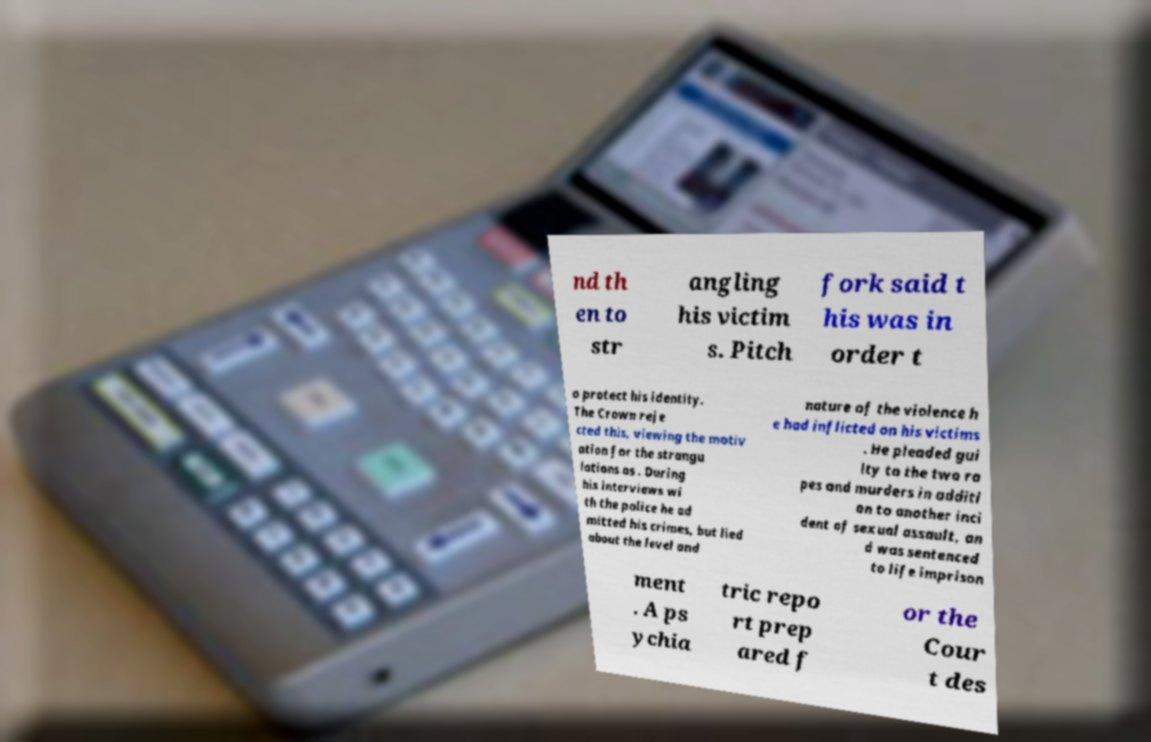Please read and relay the text visible in this image. What does it say? nd th en to str angling his victim s. Pitch fork said t his was in order t o protect his identity. The Crown reje cted this, viewing the motiv ation for the strangu lations as . During his interviews wi th the police he ad mitted his crimes, but lied about the level and nature of the violence h e had inflicted on his victims . He pleaded gui lty to the two ra pes and murders in additi on to another inci dent of sexual assault, an d was sentenced to life imprison ment . A ps ychia tric repo rt prep ared f or the Cour t des 